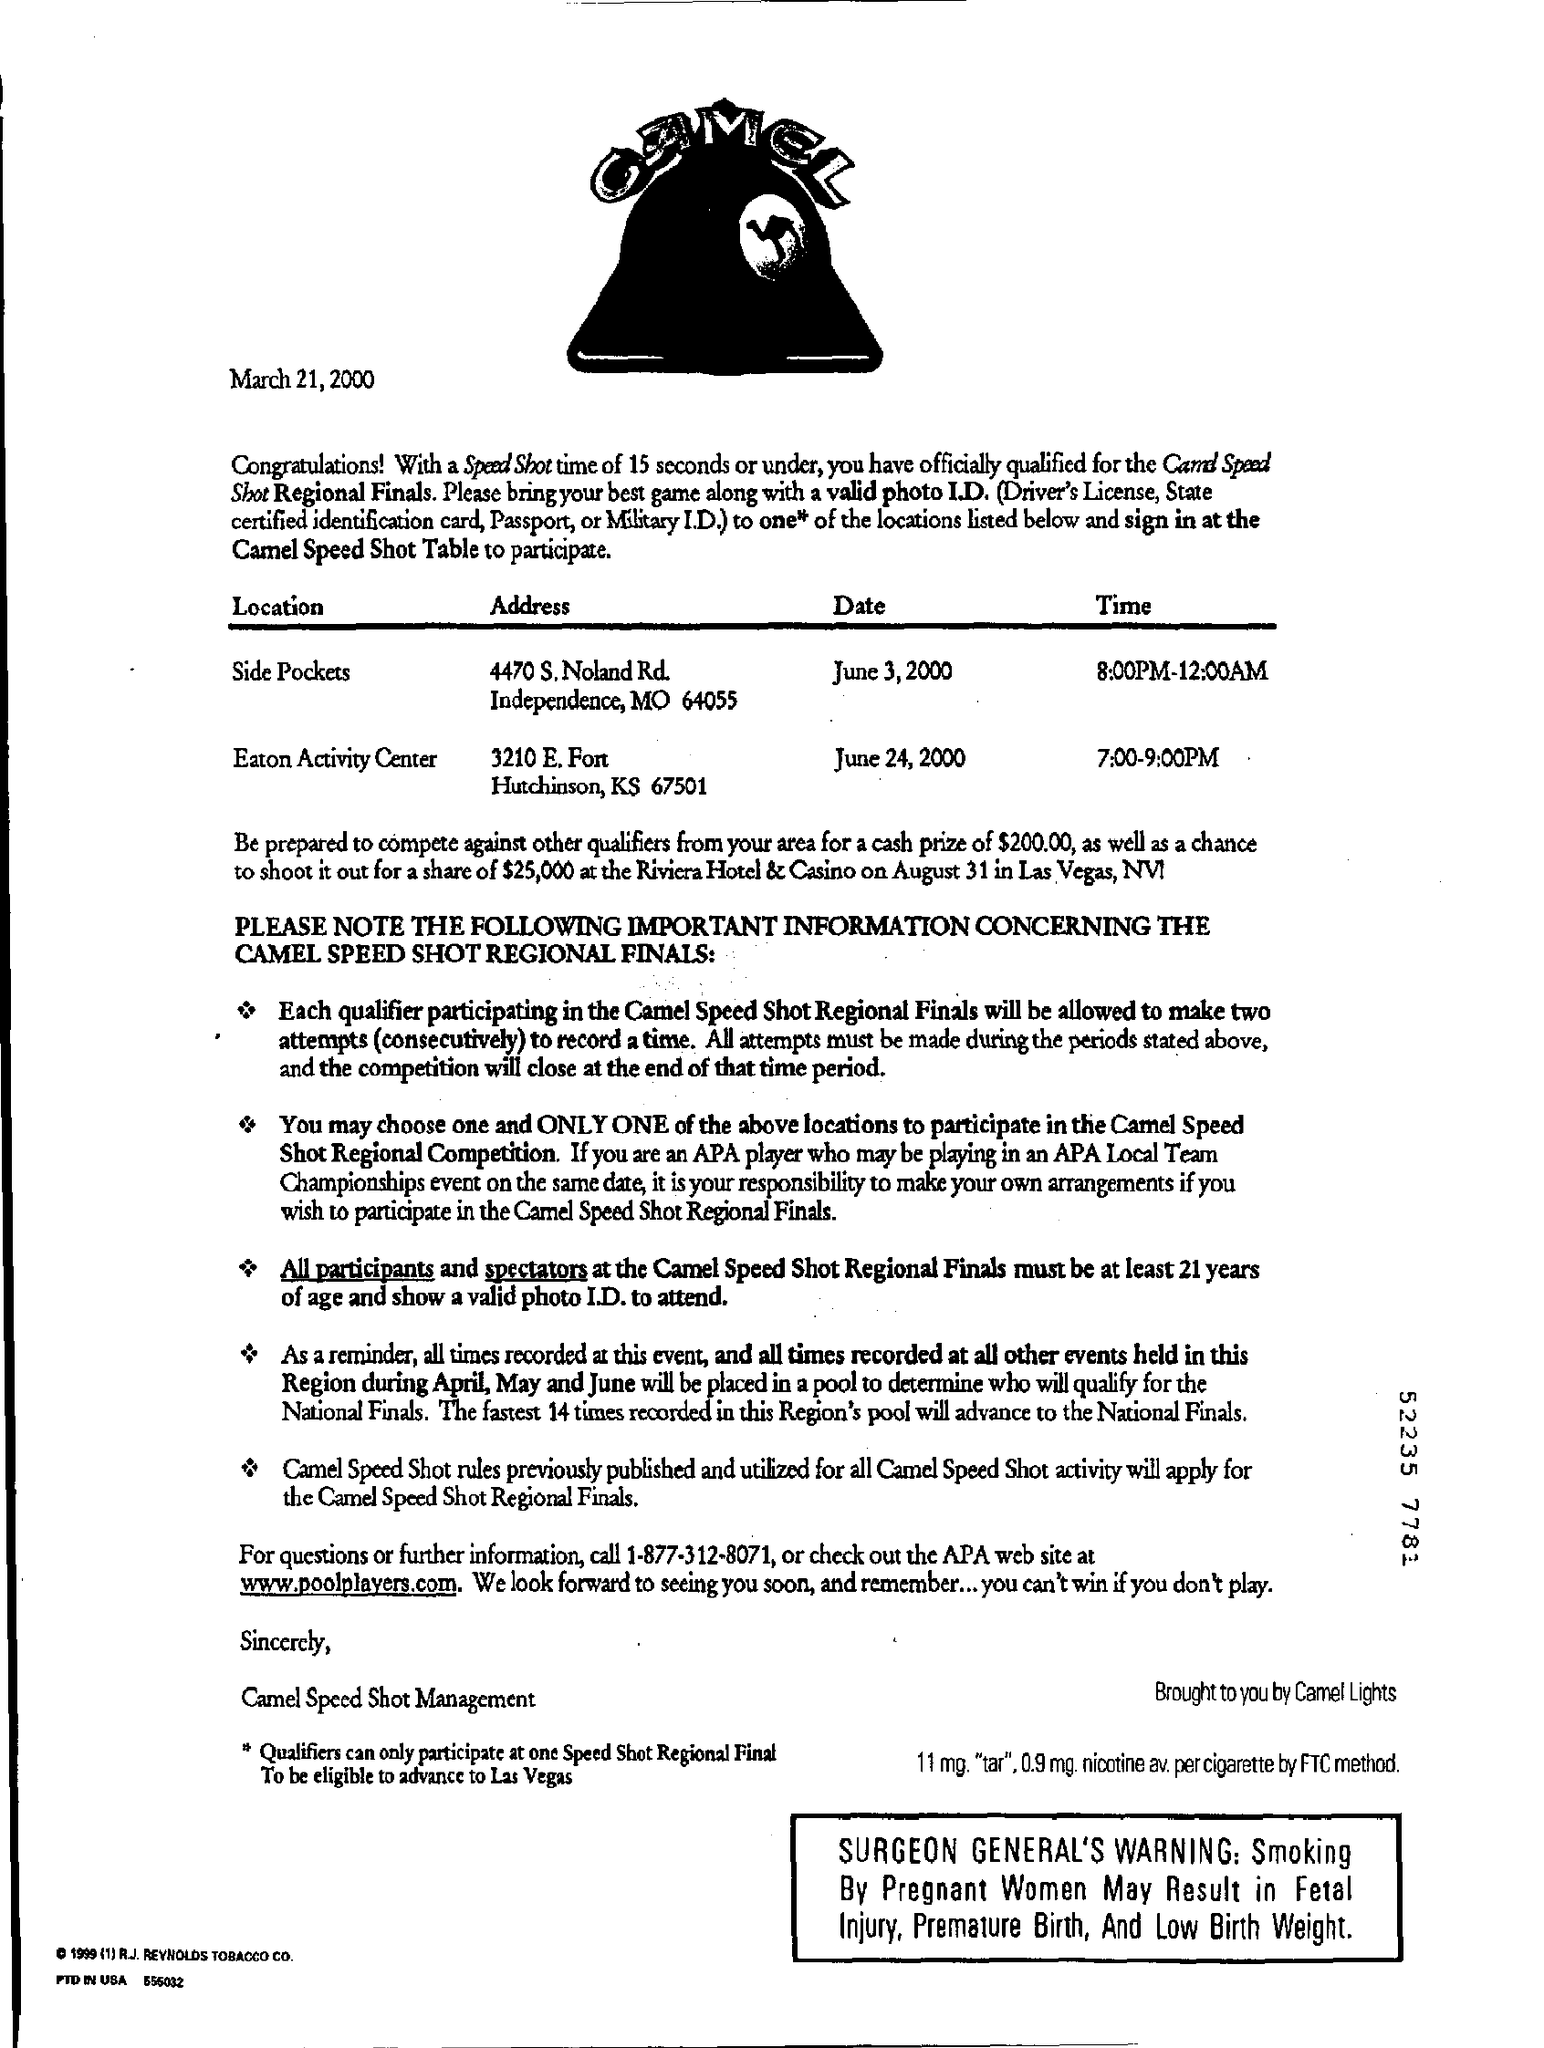Outline some significant characteristics in this image. The location of finals on June 3, 2000, was Side Pockets. I have located a website, [www.poolplayers.com](http://www.poolplayers.com), that provides information on quarries and related topics. This website can be a valuable resource for those seeking further information on the subject. The cash price for qualifiers in our area is $200.00. 